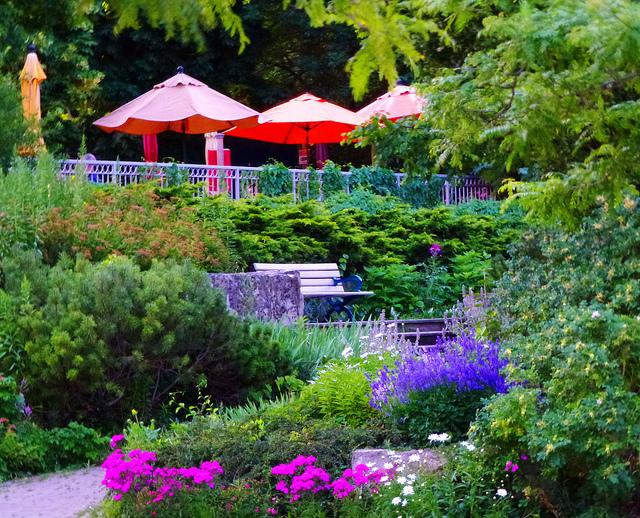What color are the flowers?
Short answer required. Purple. Is it raining?
Short answer required. No. What does flowers smell like?
Keep it brief. Sweet. 